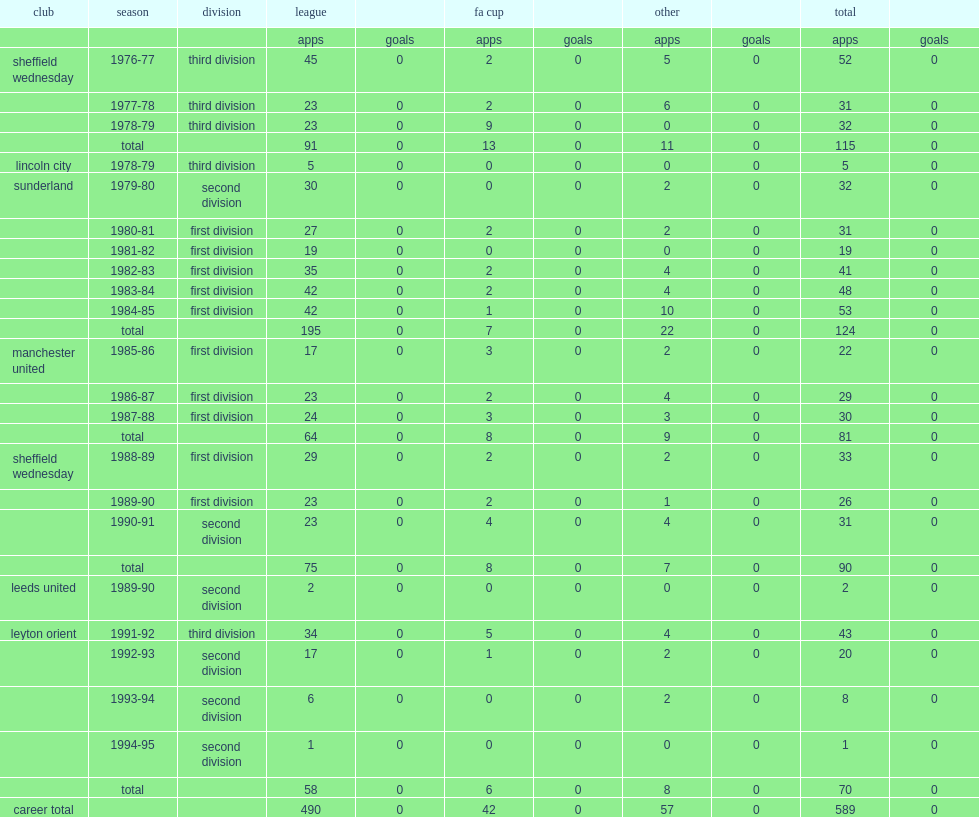Which club did chris turner play for sunderland in the second division in 1979-80? Sunderland. 